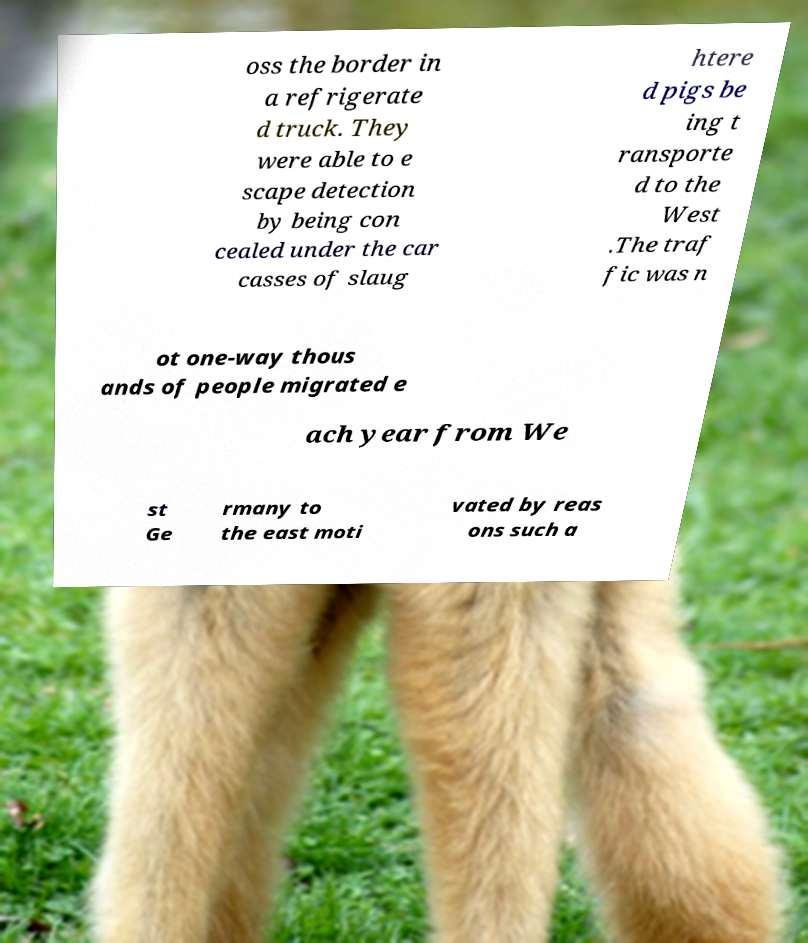For documentation purposes, I need the text within this image transcribed. Could you provide that? oss the border in a refrigerate d truck. They were able to e scape detection by being con cealed under the car casses of slaug htere d pigs be ing t ransporte d to the West .The traf fic was n ot one-way thous ands of people migrated e ach year from We st Ge rmany to the east moti vated by reas ons such a 